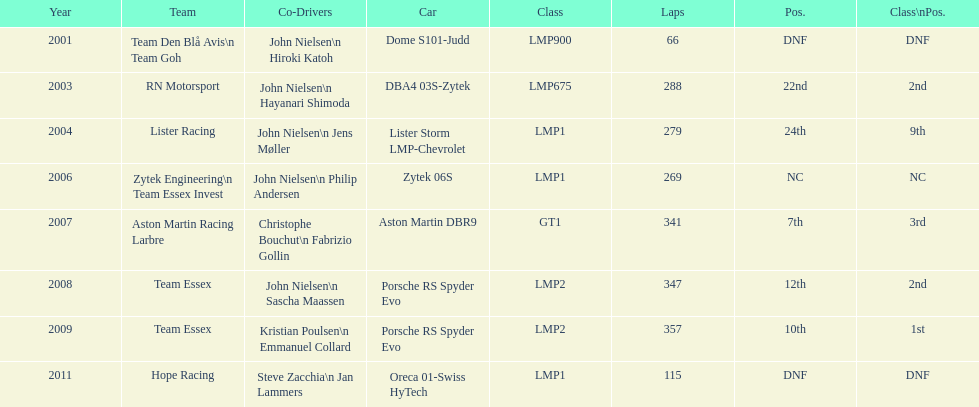Would you be able to parse every entry in this table? {'header': ['Year', 'Team', 'Co-Drivers', 'Car', 'Class', 'Laps', 'Pos.', 'Class\\nPos.'], 'rows': [['2001', 'Team Den Blå Avis\\n Team Goh', 'John Nielsen\\n Hiroki Katoh', 'Dome S101-Judd', 'LMP900', '66', 'DNF', 'DNF'], ['2003', 'RN Motorsport', 'John Nielsen\\n Hayanari Shimoda', 'DBA4 03S-Zytek', 'LMP675', '288', '22nd', '2nd'], ['2004', 'Lister Racing', 'John Nielsen\\n Jens Møller', 'Lister Storm LMP-Chevrolet', 'LMP1', '279', '24th', '9th'], ['2006', 'Zytek Engineering\\n Team Essex Invest', 'John Nielsen\\n Philip Andersen', 'Zytek 06S', 'LMP1', '269', 'NC', 'NC'], ['2007', 'Aston Martin Racing Larbre', 'Christophe Bouchut\\n Fabrizio Gollin', 'Aston Martin DBR9', 'GT1', '341', '7th', '3rd'], ['2008', 'Team Essex', 'John Nielsen\\n Sascha Maassen', 'Porsche RS Spyder Evo', 'LMP2', '347', '12th', '2nd'], ['2009', 'Team Essex', 'Kristian Poulsen\\n Emmanuel Collard', 'Porsche RS Spyder Evo', 'LMP2', '357', '10th', '1st'], ['2011', 'Hope Racing', 'Steve Zacchia\\n Jan Lammers', 'Oreca 01-Swiss HyTech', 'LMP1', '115', 'DNF', 'DNF']]} In how many competitions was the porsche rs spyder utilized? 2. 